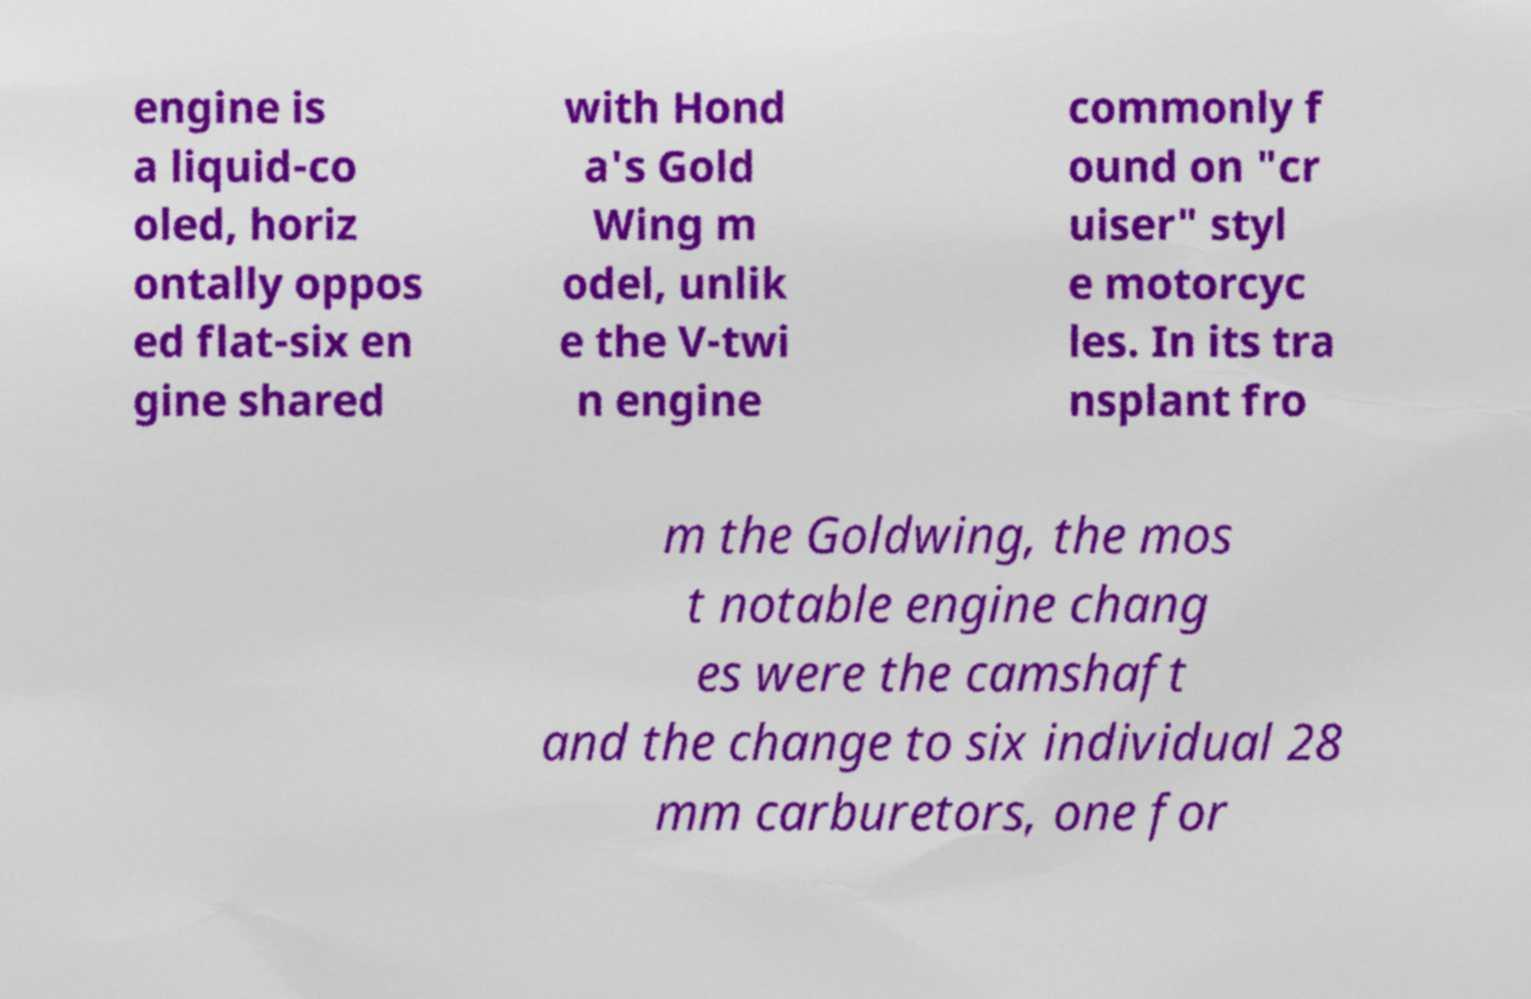Please read and relay the text visible in this image. What does it say? engine is a liquid-co oled, horiz ontally oppos ed flat-six en gine shared with Hond a's Gold Wing m odel, unlik e the V-twi n engine commonly f ound on "cr uiser" styl e motorcyc les. In its tra nsplant fro m the Goldwing, the mos t notable engine chang es were the camshaft and the change to six individual 28 mm carburetors, one for 